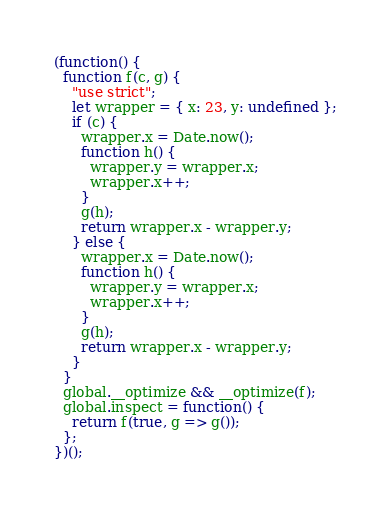<code> <loc_0><loc_0><loc_500><loc_500><_JavaScript_>(function() {
  function f(c, g) {
    "use strict";
    let wrapper = { x: 23, y: undefined };
    if (c) {
      wrapper.x = Date.now();
      function h() {
        wrapper.y = wrapper.x;
        wrapper.x++;
      }
      g(h);
      return wrapper.x - wrapper.y;
    } else {
      wrapper.x = Date.now();
      function h() {
        wrapper.y = wrapper.x;
        wrapper.x++;
      }
      g(h);
      return wrapper.x - wrapper.y;
    }
  }
  global.__optimize && __optimize(f);
  global.inspect = function() {
    return f(true, g => g());
  };
})();
</code> 